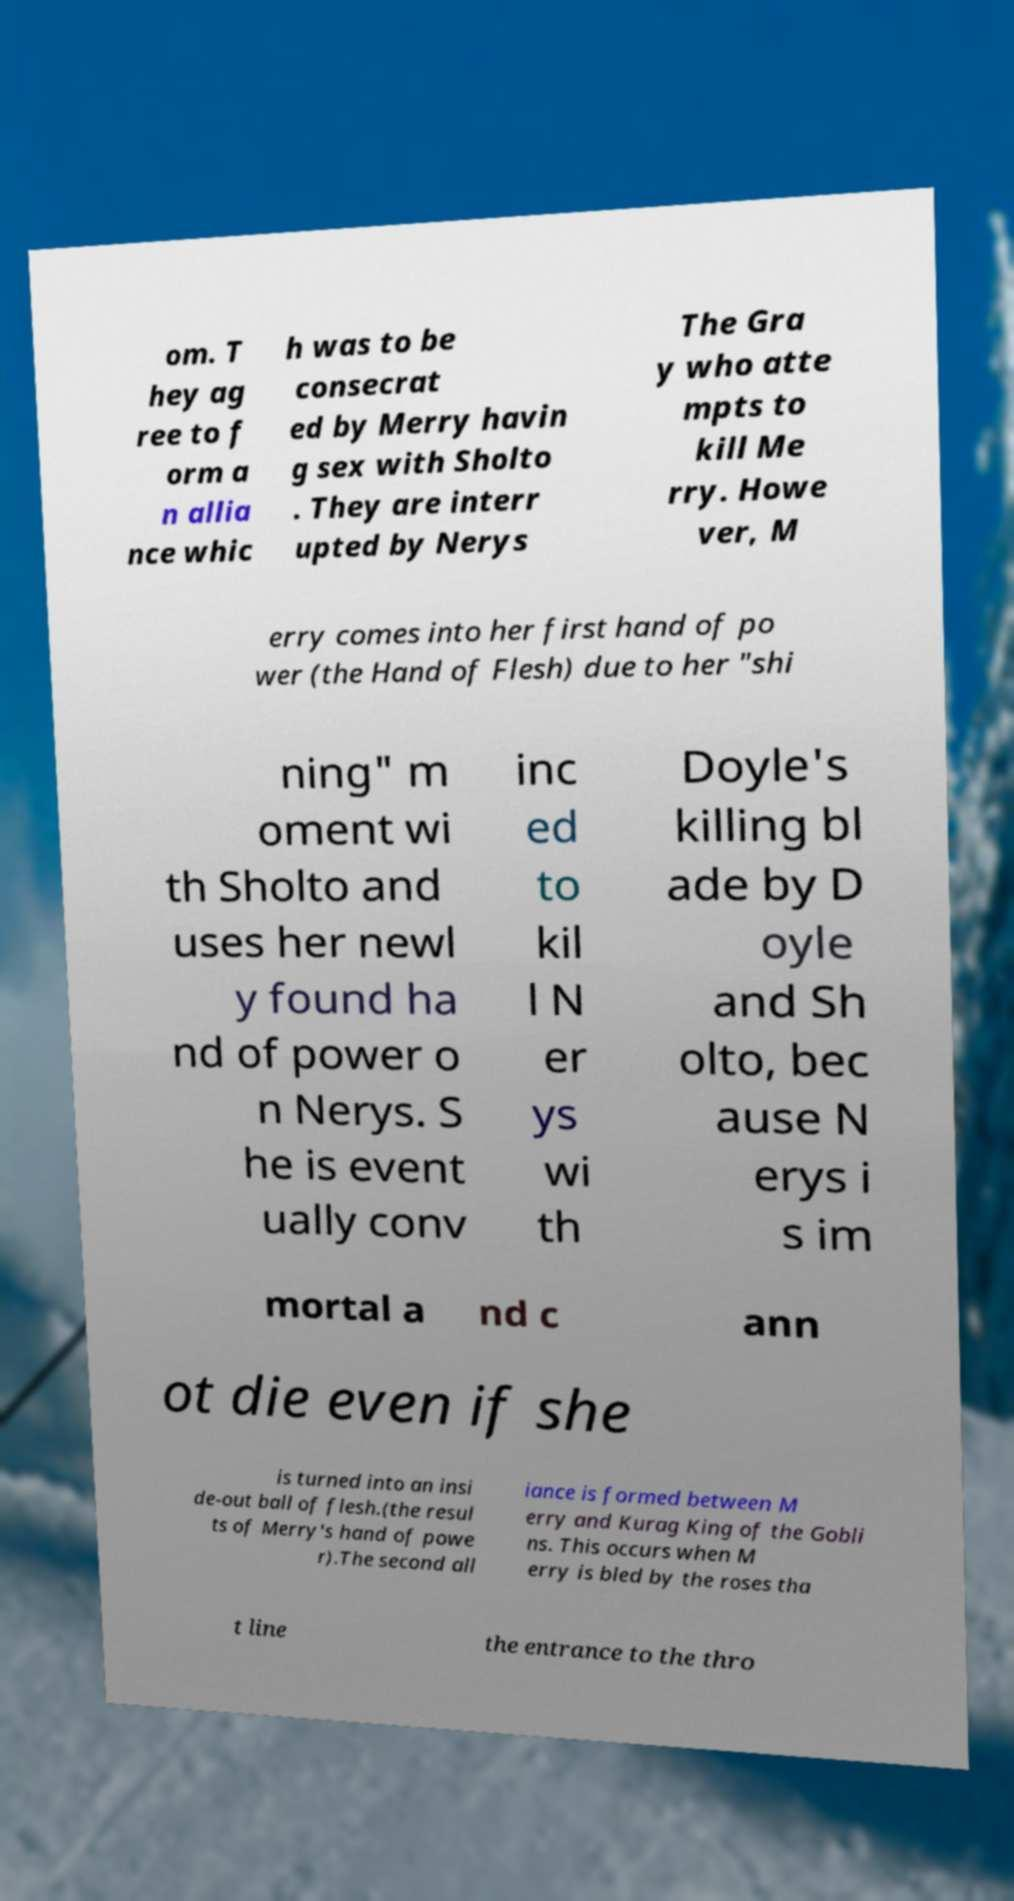Can you accurately transcribe the text from the provided image for me? om. T hey ag ree to f orm a n allia nce whic h was to be consecrat ed by Merry havin g sex with Sholto . They are interr upted by Nerys The Gra y who atte mpts to kill Me rry. Howe ver, M erry comes into her first hand of po wer (the Hand of Flesh) due to her "shi ning" m oment wi th Sholto and uses her newl y found ha nd of power o n Nerys. S he is event ually conv inc ed to kil l N er ys wi th Doyle's killing bl ade by D oyle and Sh olto, bec ause N erys i s im mortal a nd c ann ot die even if she is turned into an insi de-out ball of flesh.(the resul ts of Merry's hand of powe r).The second all iance is formed between M erry and Kurag King of the Gobli ns. This occurs when M erry is bled by the roses tha t line the entrance to the thro 